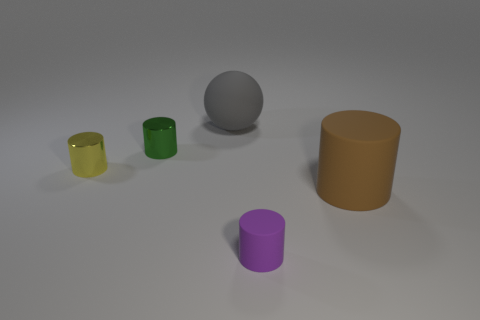There is a object that is the same size as the brown matte cylinder; what is its color?
Keep it short and to the point. Gray. The big thing that is on the left side of the large object that is on the right side of the small thing that is in front of the tiny yellow metallic thing is what shape?
Provide a short and direct response. Sphere. How many objects are either green rubber balls or purple matte objects that are right of the big matte sphere?
Make the answer very short. 1. There is a metallic cylinder behind the yellow cylinder; does it have the same size as the tiny purple cylinder?
Your answer should be very brief. Yes. There is a small green cylinder that is behind the purple cylinder; what is it made of?
Your answer should be very brief. Metal. Is the number of small purple cylinders behind the big brown object the same as the number of gray matte balls to the right of the gray sphere?
Offer a very short reply. Yes. The other tiny metallic object that is the same shape as the yellow metallic object is what color?
Keep it short and to the point. Green. Are there any other things of the same color as the tiny rubber cylinder?
Your response must be concise. No. How many rubber things are small green objects or gray cylinders?
Your answer should be compact. 0. Is the color of the small rubber object the same as the matte ball?
Offer a very short reply. No. 